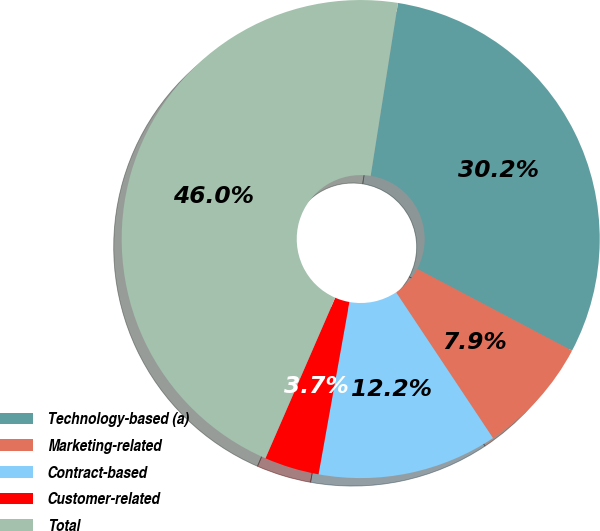Convert chart. <chart><loc_0><loc_0><loc_500><loc_500><pie_chart><fcel>Technology-based (a)<fcel>Marketing-related<fcel>Contract-based<fcel>Customer-related<fcel>Total<nl><fcel>30.24%<fcel>7.93%<fcel>12.16%<fcel>3.7%<fcel>45.97%<nl></chart> 